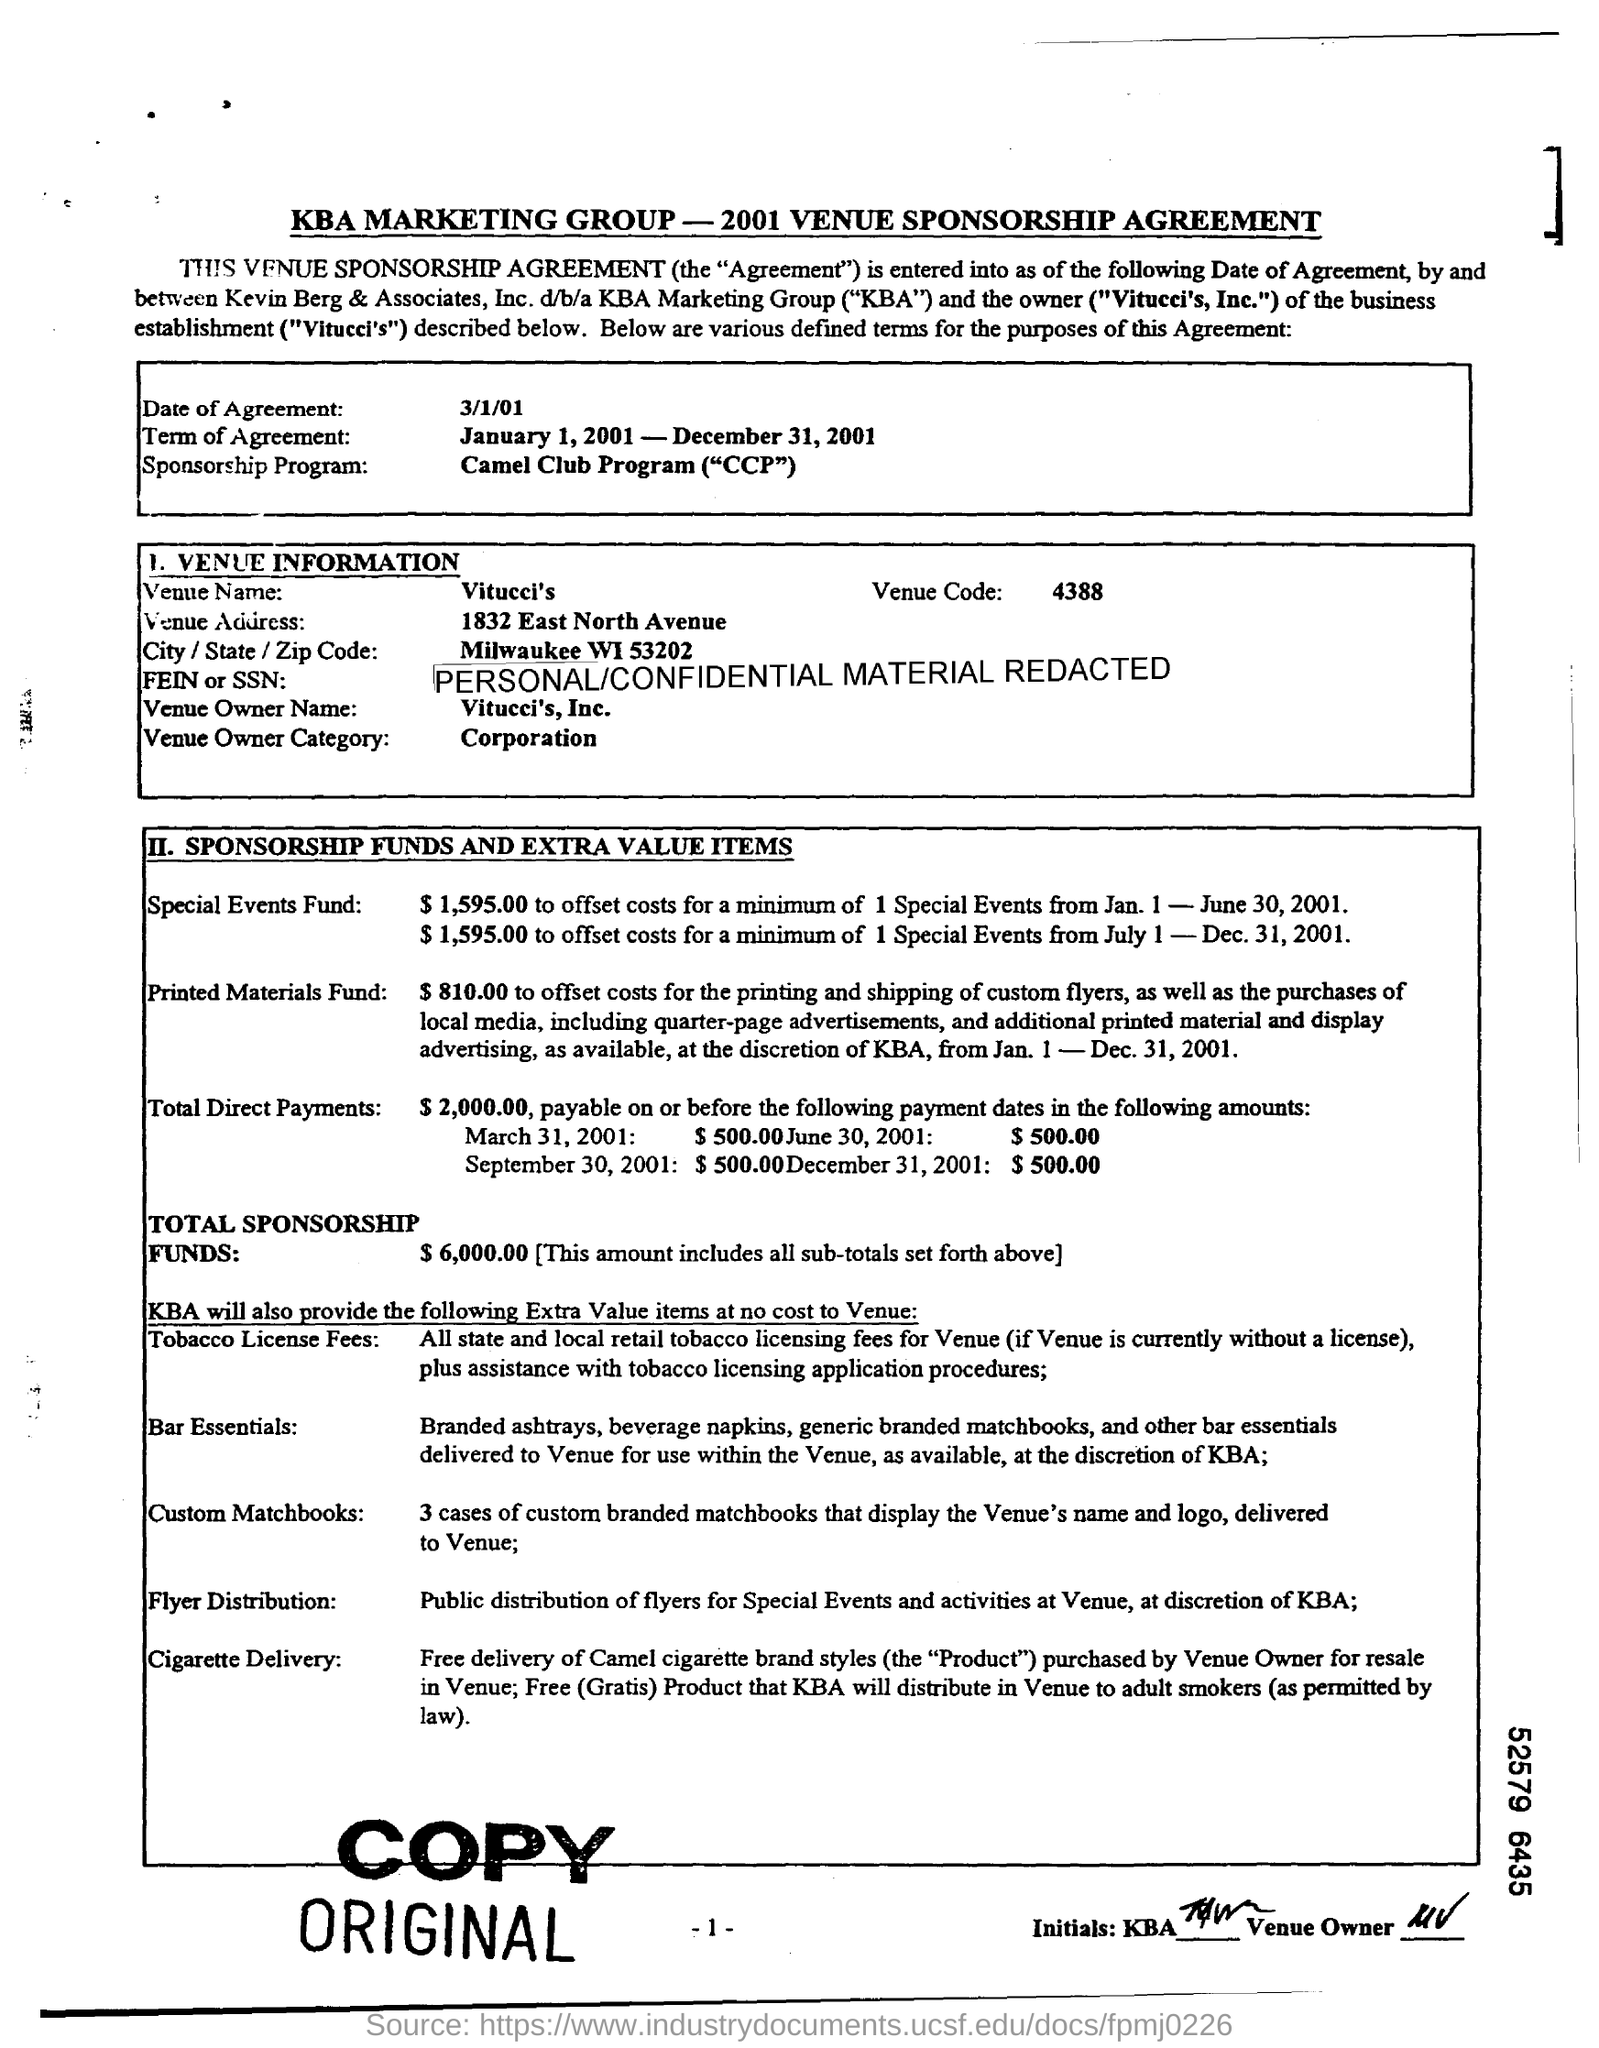Highlight a few significant elements in this photo. The total amount of sponsorship funds is $6,000.00. What is the name of the venue? It is Vitucci's. What is the date of agreement? March 1, 2001. The Venue Code is 4388. The term of agreement is from January 1, 2001, to December 31, 2001. 